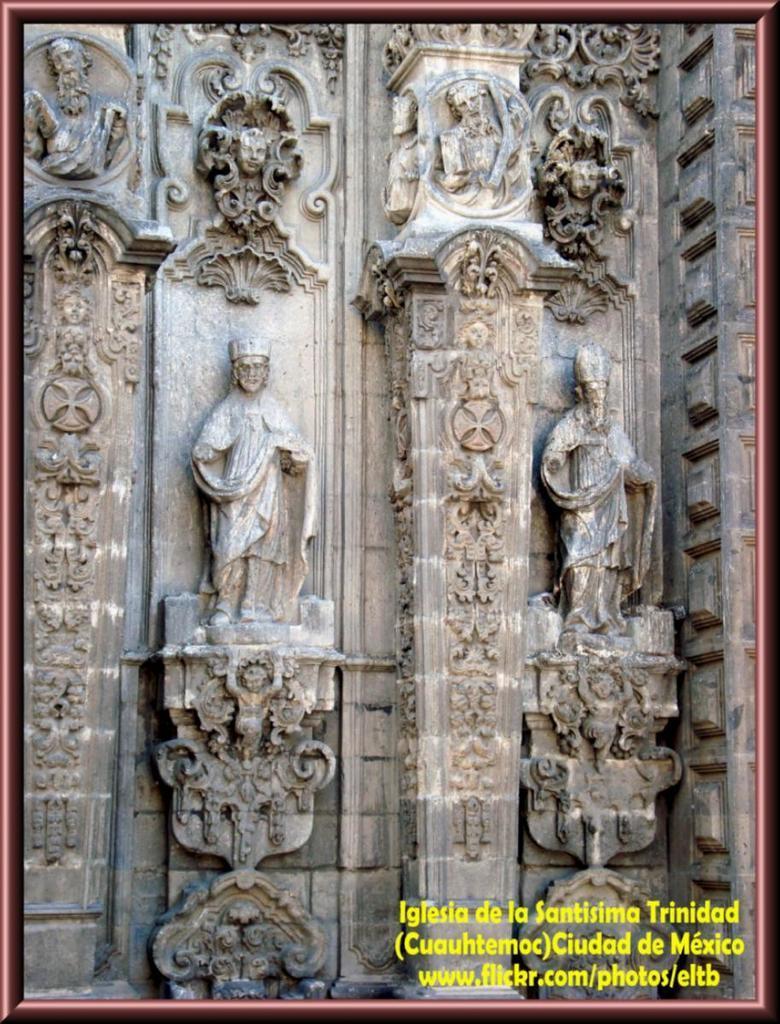Describe this image in one or two sentences. In this image there are sculptures and there is some text written in the bottom right of the image. 